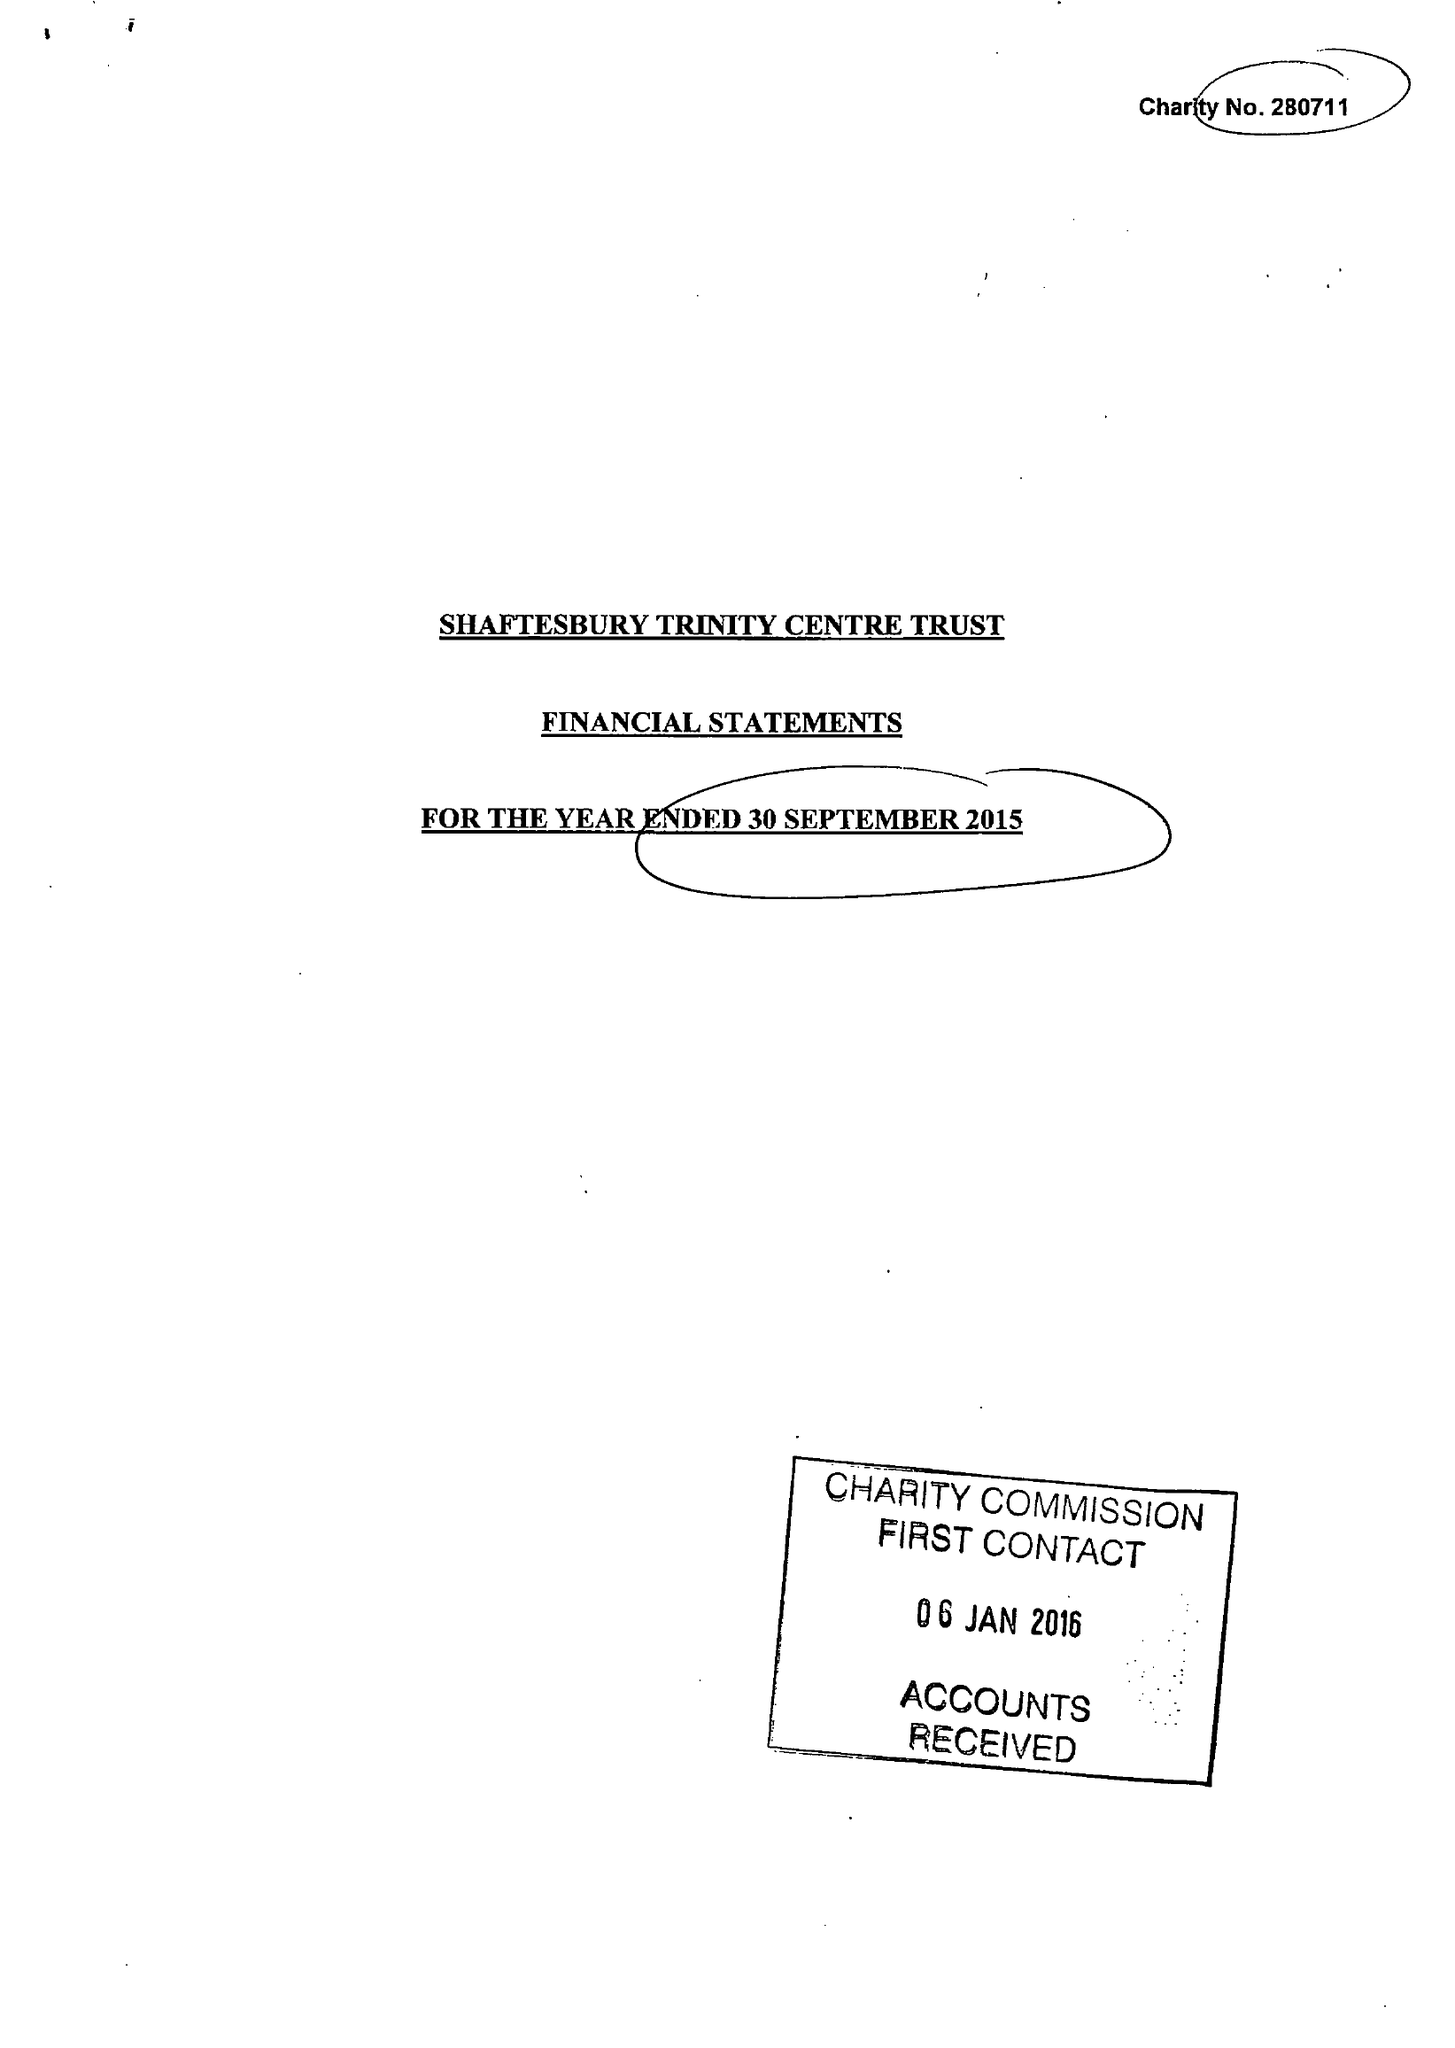What is the value for the address__postcode?
Answer the question using a single word or phrase. SP8 5JH 